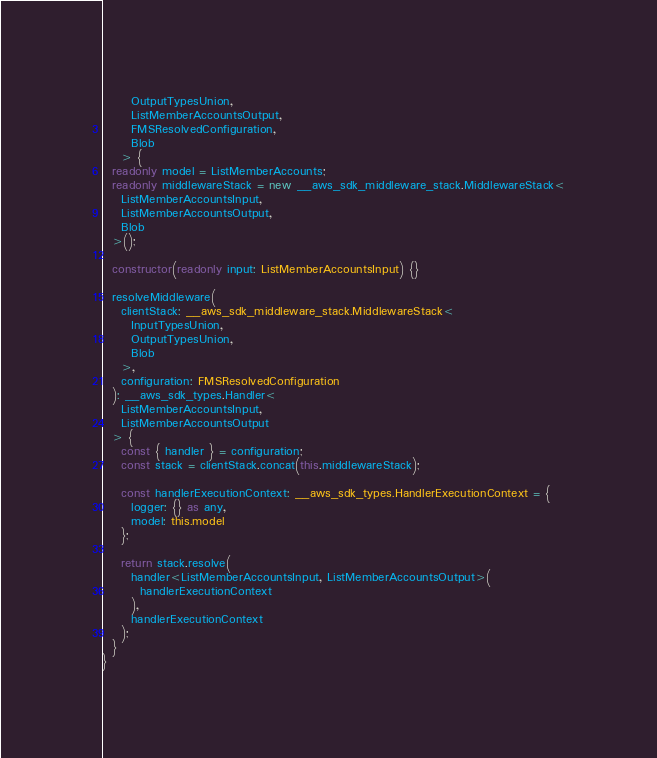<code> <loc_0><loc_0><loc_500><loc_500><_TypeScript_>      OutputTypesUnion,
      ListMemberAccountsOutput,
      FMSResolvedConfiguration,
      Blob
    > {
  readonly model = ListMemberAccounts;
  readonly middlewareStack = new __aws_sdk_middleware_stack.MiddlewareStack<
    ListMemberAccountsInput,
    ListMemberAccountsOutput,
    Blob
  >();

  constructor(readonly input: ListMemberAccountsInput) {}

  resolveMiddleware(
    clientStack: __aws_sdk_middleware_stack.MiddlewareStack<
      InputTypesUnion,
      OutputTypesUnion,
      Blob
    >,
    configuration: FMSResolvedConfiguration
  ): __aws_sdk_types.Handler<
    ListMemberAccountsInput,
    ListMemberAccountsOutput
  > {
    const { handler } = configuration;
    const stack = clientStack.concat(this.middlewareStack);

    const handlerExecutionContext: __aws_sdk_types.HandlerExecutionContext = {
      logger: {} as any,
      model: this.model
    };

    return stack.resolve(
      handler<ListMemberAccountsInput, ListMemberAccountsOutput>(
        handlerExecutionContext
      ),
      handlerExecutionContext
    );
  }
}
</code> 